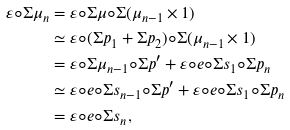<formula> <loc_0><loc_0><loc_500><loc_500>\varepsilon \circ \Sigma \mu _ { n } & = \varepsilon \circ \Sigma \mu \circ \Sigma ( \mu _ { n - 1 } \times 1 ) \\ & \simeq \varepsilon \circ ( \Sigma p _ { 1 } + \Sigma p _ { 2 } ) \circ \Sigma ( \mu _ { n - 1 } \times 1 ) \\ & = \varepsilon \circ \Sigma \mu _ { n - 1 } \circ \Sigma p ^ { \prime } + \varepsilon \circ e \circ \Sigma s _ { 1 } \circ \Sigma p _ { n } \\ & \simeq \varepsilon \circ e \circ \Sigma s _ { n - 1 } \circ \Sigma p ^ { \prime } + \varepsilon \circ e \circ \Sigma s _ { 1 } \circ \Sigma p _ { n } \\ & = \varepsilon \circ e \circ \Sigma s _ { n } ,</formula> 